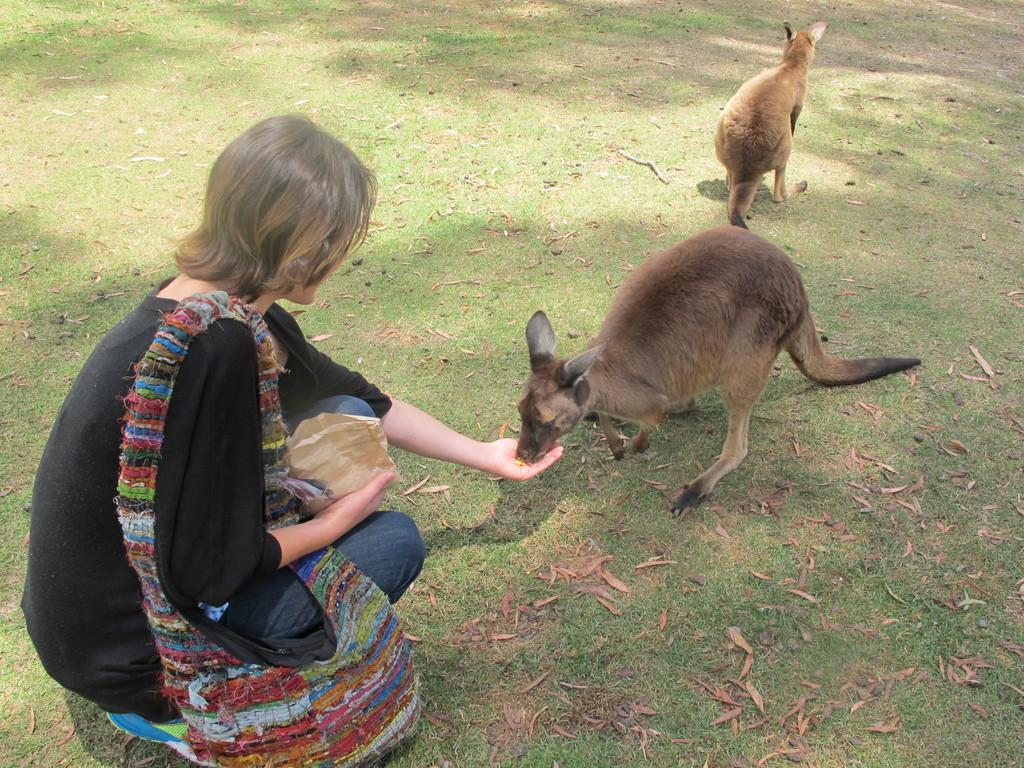Who is the main subject in the image? There is a lady in the image. What is the lady wearing? The lady is wearing a bag. What is the lady holding in her hand? The lady is holding something in her hand. What animals are present in the image? There are kangaroos in front of the lady. What type of terrain is visible in the image? There is grass on the ground in the image. What type of wine is the lady drinking in the image? There is no wine present in the image; the lady is not drinking anything. 